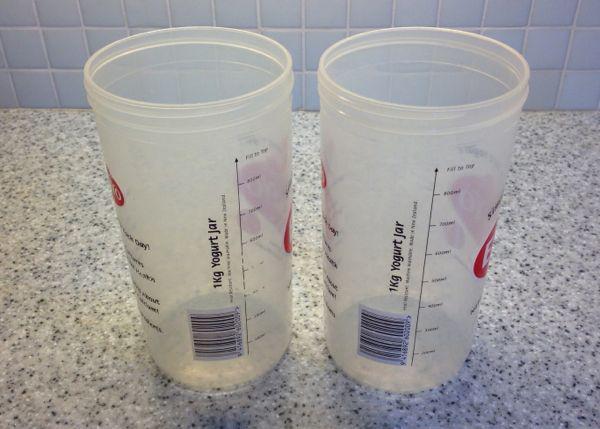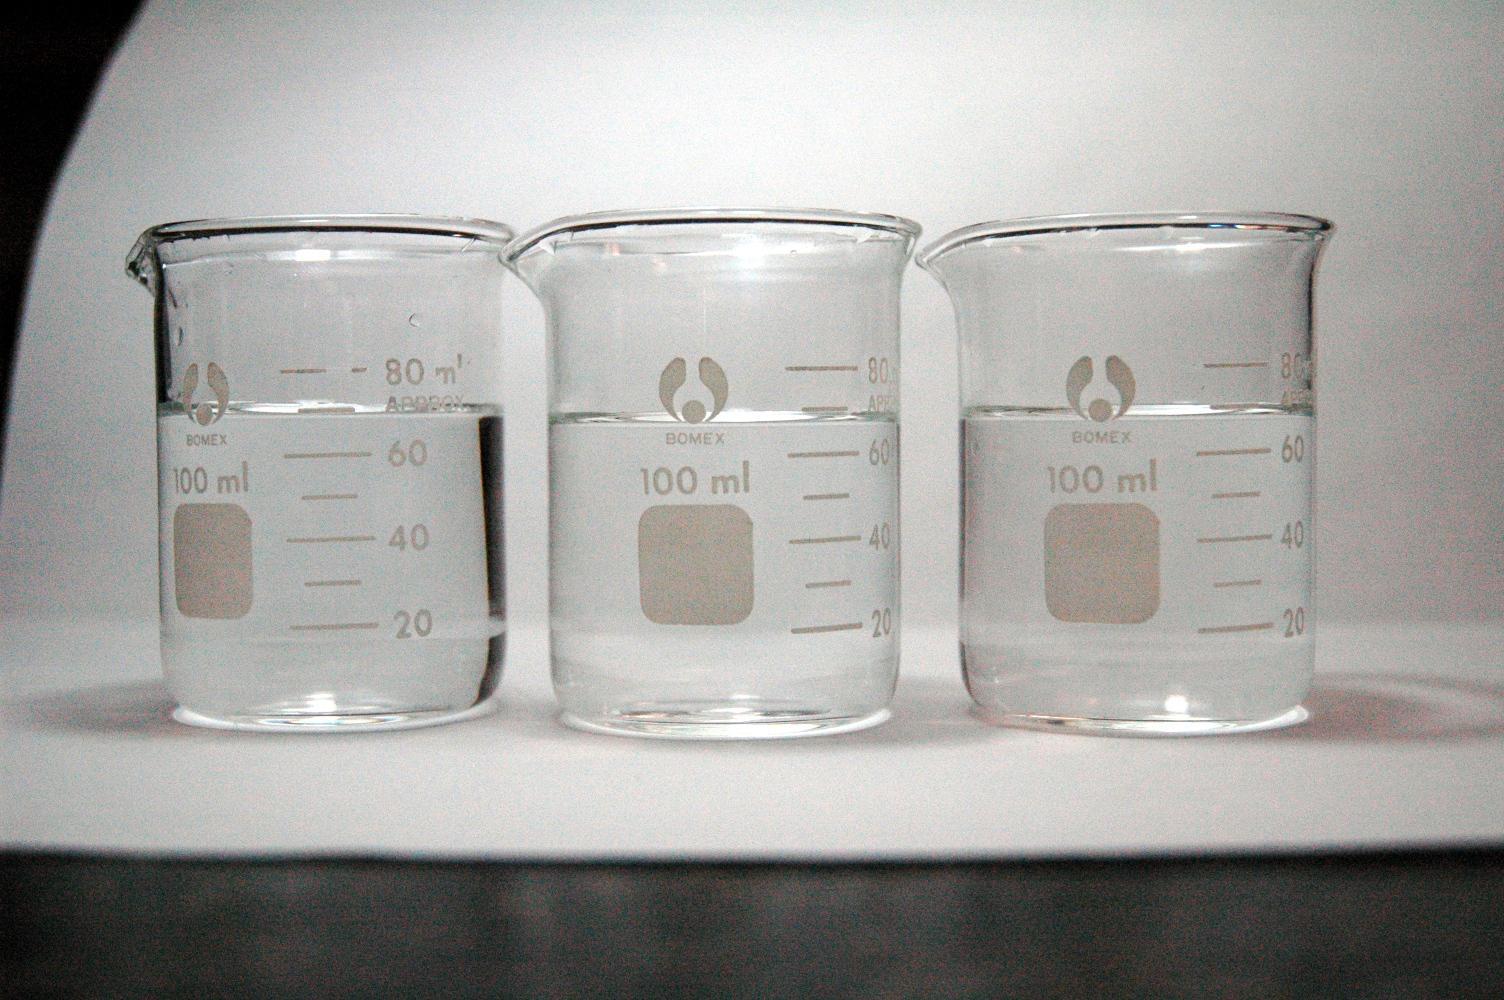The first image is the image on the left, the second image is the image on the right. Assess this claim about the two images: "A long thin glass stick is in at least one beaker.". Correct or not? Answer yes or no. No. The first image is the image on the left, the second image is the image on the right. For the images shown, is this caption "At least one of the photos contains three or more pieces of glassware." true? Answer yes or no. Yes. 